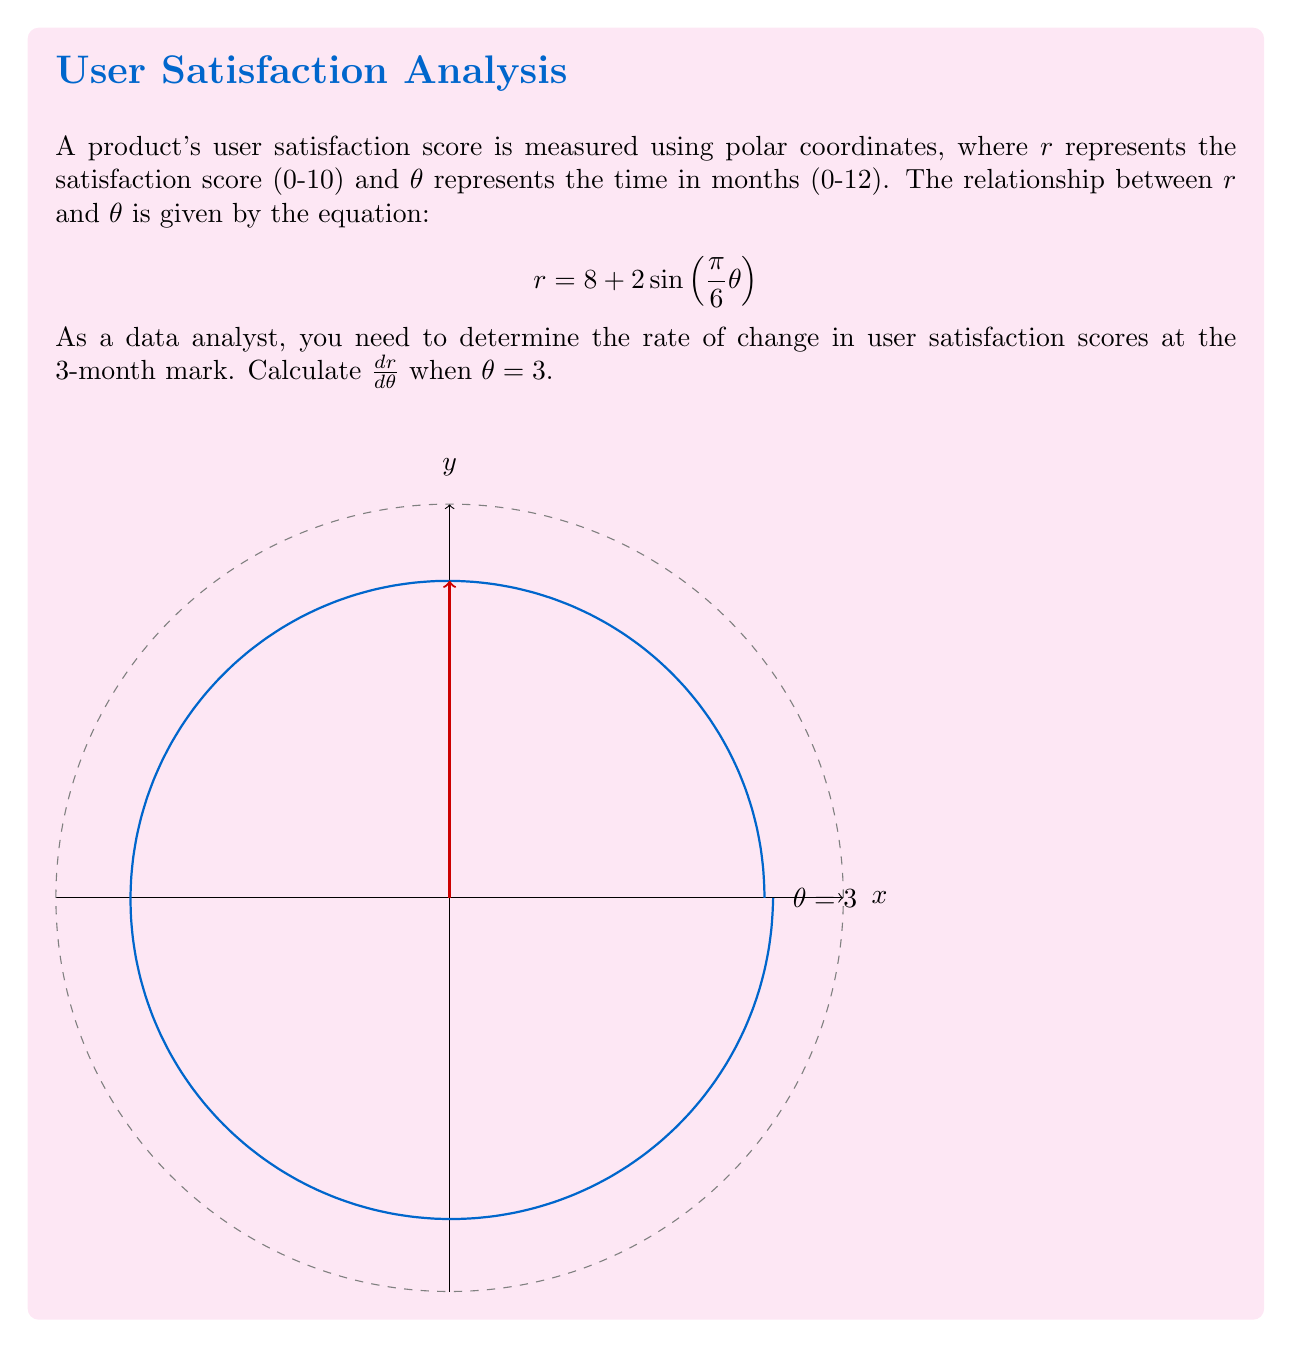Could you help me with this problem? To solve this problem, we need to follow these steps:

1) First, we need to find the derivative of $r$ with respect to $\theta$. We can do this using the chain rule:

   $$\frac{dr}{d\theta} = \frac{d}{d\theta}[8 + 2\sin(\frac{\pi}{6}\theta)]$$
   $$\frac{dr}{d\theta} = 2 \cdot \frac{d}{d\theta}[\sin(\frac{\pi}{6}\theta)]$$
   $$\frac{dr}{d\theta} = 2 \cdot \cos(\frac{\pi}{6}\theta) \cdot \frac{\pi}{6}$$
   $$\frac{dr}{d\theta} = \frac{\pi}{3}\cos(\frac{\pi}{6}\theta)$$

2) Now that we have the derivative, we need to evaluate it at $\theta = 3$:

   $$\frac{dr}{d\theta}\bigg|_{\theta=3} = \frac{\pi}{3}\cos(\frac{\pi}{6} \cdot 3)$$
   $$= \frac{\pi}{3}\cos(\frac{\pi}{2})$$

3) We know that $\cos(\frac{\pi}{2}) = 0$, so:

   $$\frac{dr}{d\theta}\bigg|_{\theta=3} = \frac{\pi}{3} \cdot 0 = 0$$

Therefore, the rate of change in user satisfaction scores at the 3-month mark is 0.
Answer: $0$ 